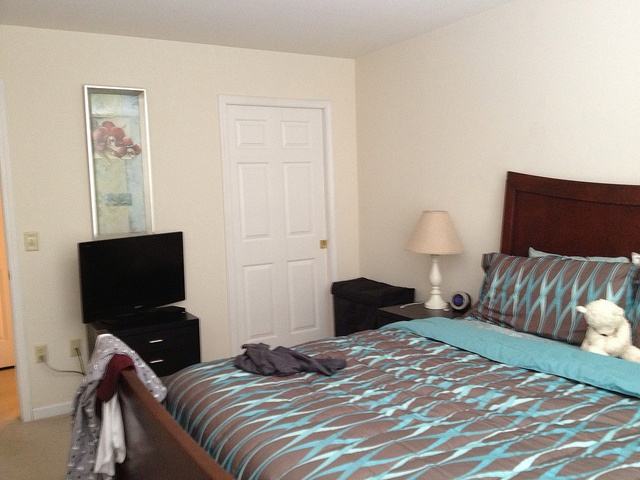Describe the objects in this image and their specific colors. I can see bed in darkgray, gray, and black tones, tv in darkgray, black, and gray tones, teddy bear in darkgray, beige, and tan tones, and clock in darkgray, gray, black, and navy tones in this image. 